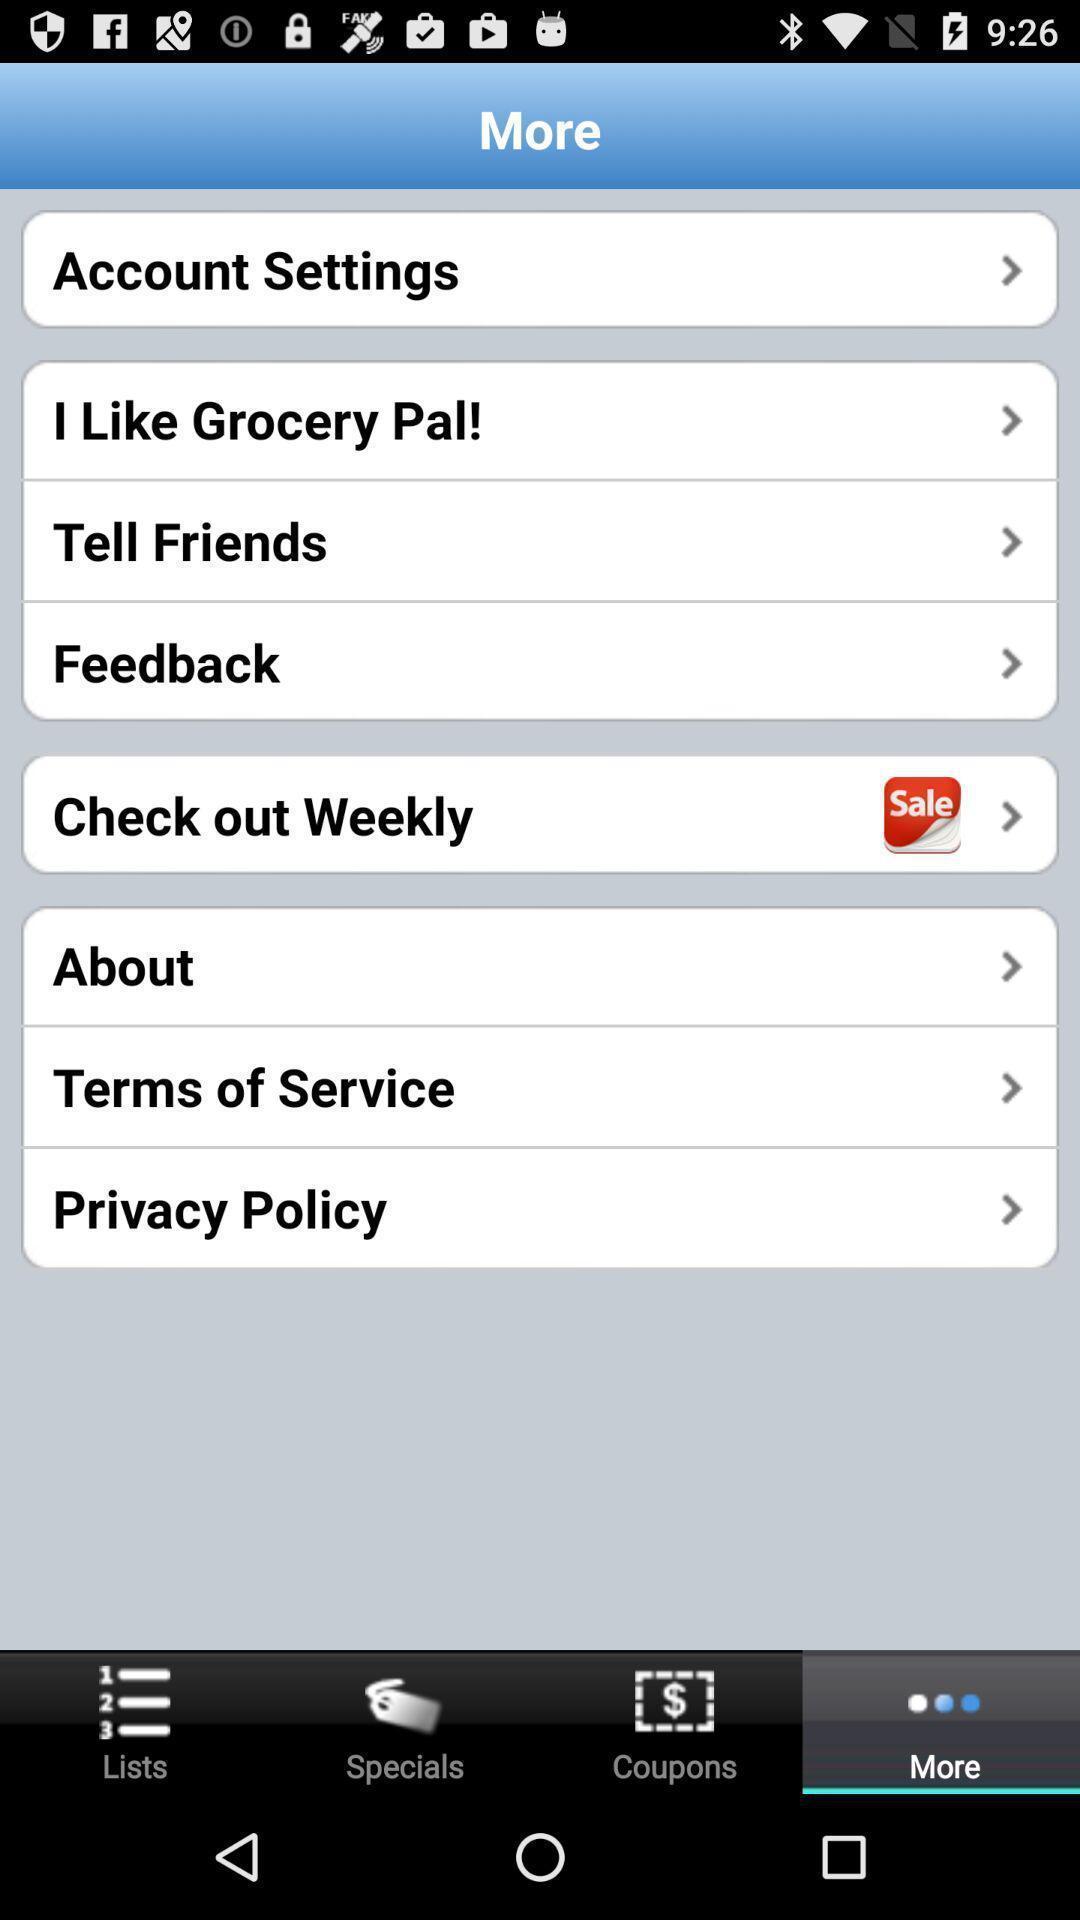Summarize the information in this screenshot. Page displaying list of more options. 